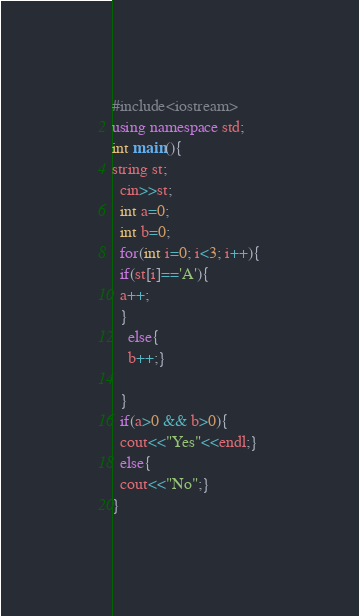<code> <loc_0><loc_0><loc_500><loc_500><_C++_>#include<iostream>
using namespace std;
int main(){
string st;
  cin>>st;
  int a=0;
  int b=0;
  for(int i=0; i<3; i++){
  if(st[i]=='A'){
  a++;
  }
    else{
    b++;}
  
  }
  if(a>0 && b>0){
  cout<<"Yes"<<endl;}
  else{
  cout<<"No";}
}</code> 